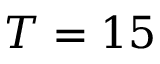<formula> <loc_0><loc_0><loc_500><loc_500>T = 1 5</formula> 